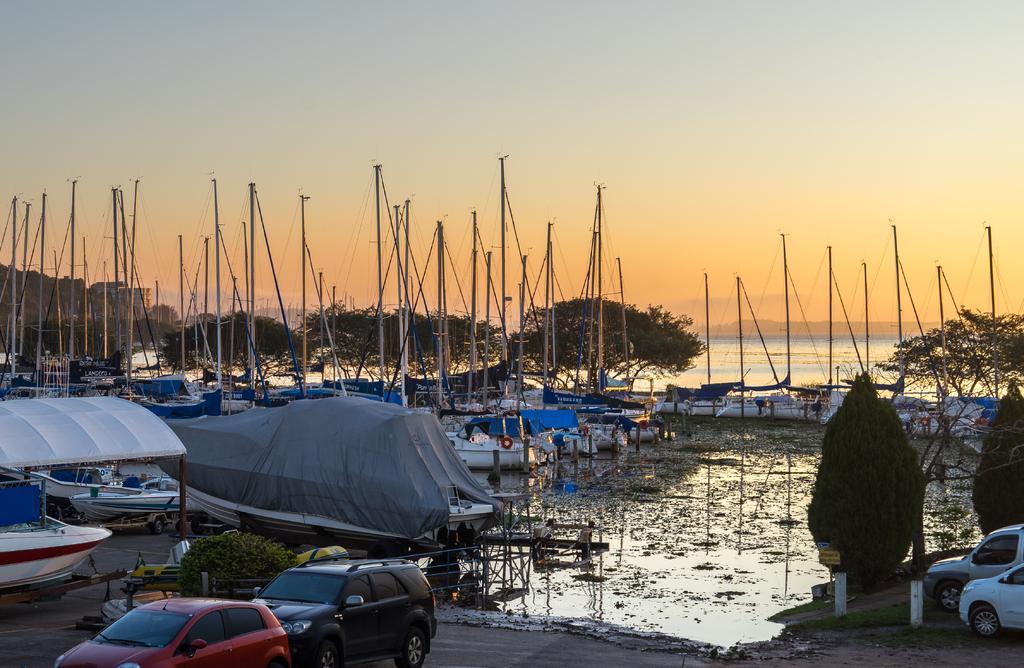In one or two sentences, can you explain what this image depicts? In the image we can see there are many boats in the water. There are poles and many vehicles. Here we can see trees, grass and a sky. 